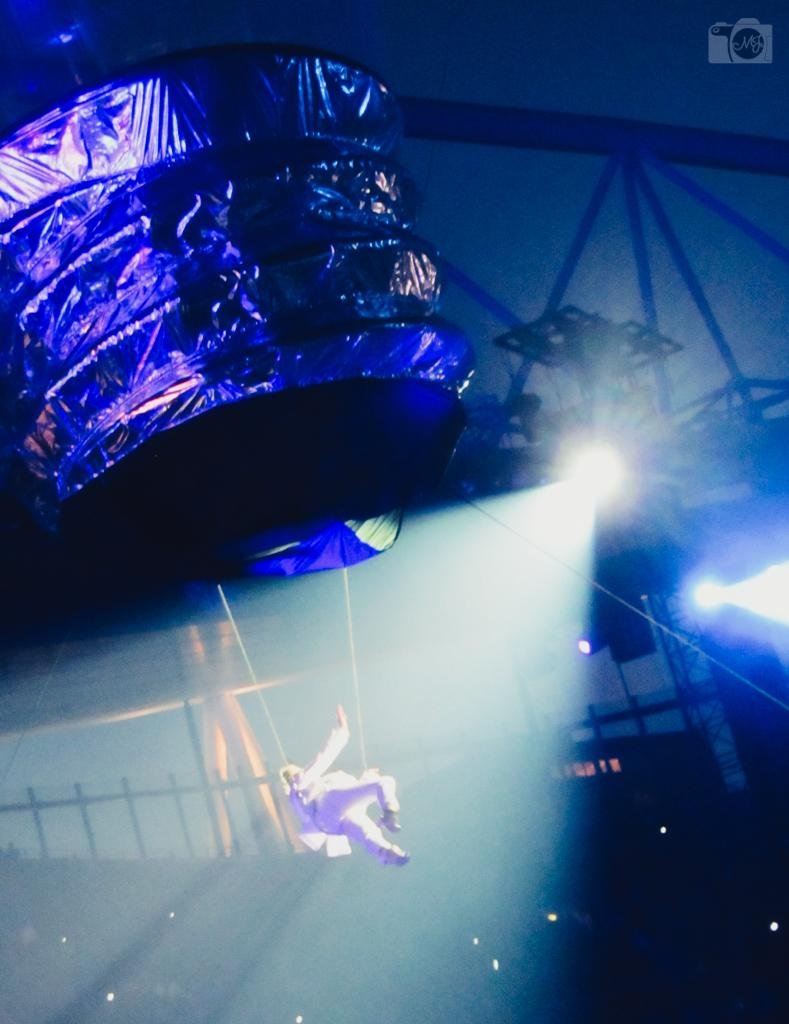What is the person in the image doing? The person is hanging from ropes in the image. What is the object connected through metal rods at the top of the image? The object connected through metal rods is not clearly described in the facts provided. What type of barrier is present in the image? There is a metal fence in the image. What can be seen providing illumination in the image? There are lights visible in the image. What type of pot is being used to lift the person in the image? There is no pot or lifting mechanism present in the image; the person is hanging from ropes. Can you see any bones in the image? There is no mention of bones in the image, and they are not visible in the provided facts. 